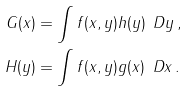Convert formula to latex. <formula><loc_0><loc_0><loc_500><loc_500>G ( x ) & = \int f ( x , y ) h ( y ) \, \ D y \, , \\ H ( y ) & = \int f ( x , y ) g ( x ) \, \ D x \, .</formula> 